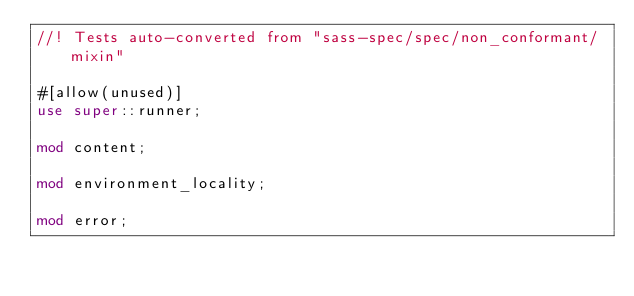Convert code to text. <code><loc_0><loc_0><loc_500><loc_500><_Rust_>//! Tests auto-converted from "sass-spec/spec/non_conformant/mixin"

#[allow(unused)]
use super::runner;

mod content;

mod environment_locality;

mod error;
</code> 